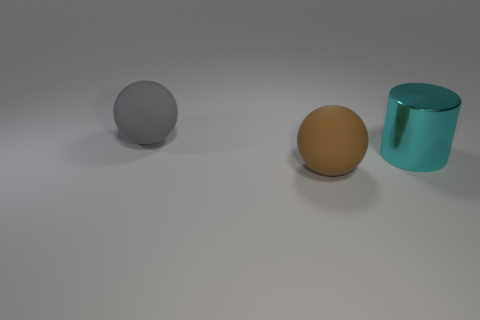Add 3 brown things. How many objects exist? 6 Subtract all brown balls. How many balls are left? 1 Subtract all cylinders. How many objects are left? 2 Subtract 0 green cylinders. How many objects are left? 3 Subtract all green cylinders. Subtract all gray blocks. How many cylinders are left? 1 Subtract all small cyan cylinders. Subtract all big brown matte balls. How many objects are left? 2 Add 3 gray rubber balls. How many gray rubber balls are left? 4 Add 2 large brown matte spheres. How many large brown matte spheres exist? 3 